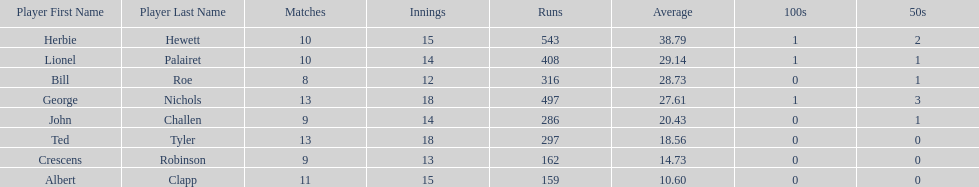How many more runs does john have than albert? 127. 